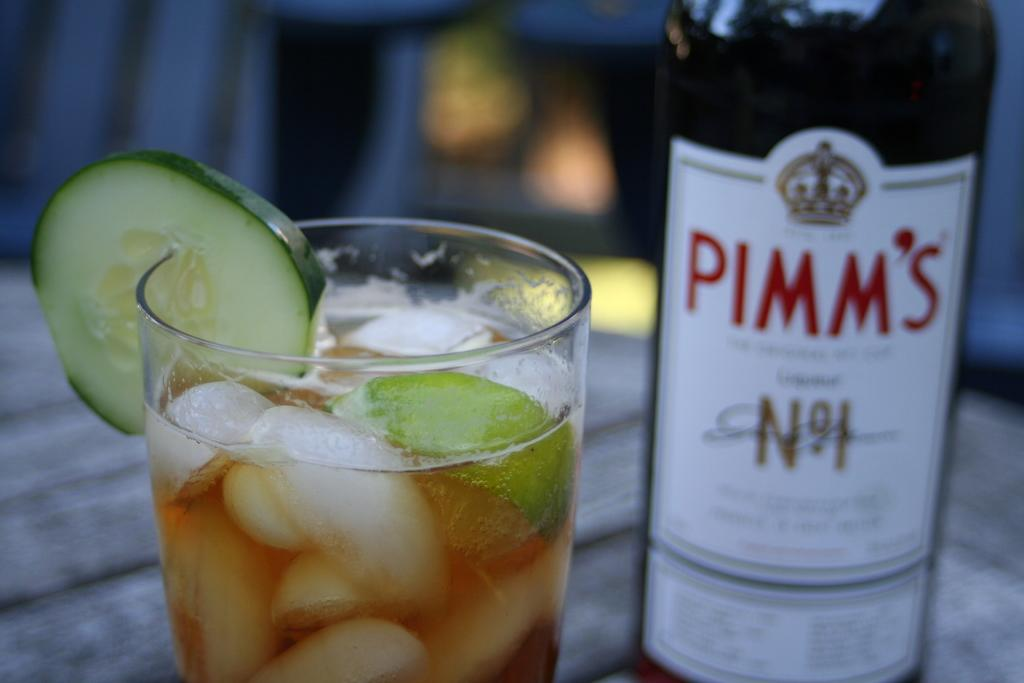<image>
Relay a brief, clear account of the picture shown. a beer bottle with Pimm's written on it 